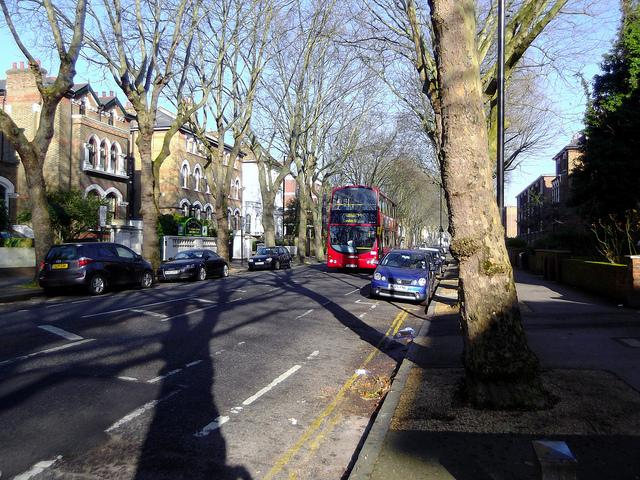Why are the cars lined up along the curb?

Choices:
A) to vacuum
B) to inspect
C) to wash
D) to park to park 